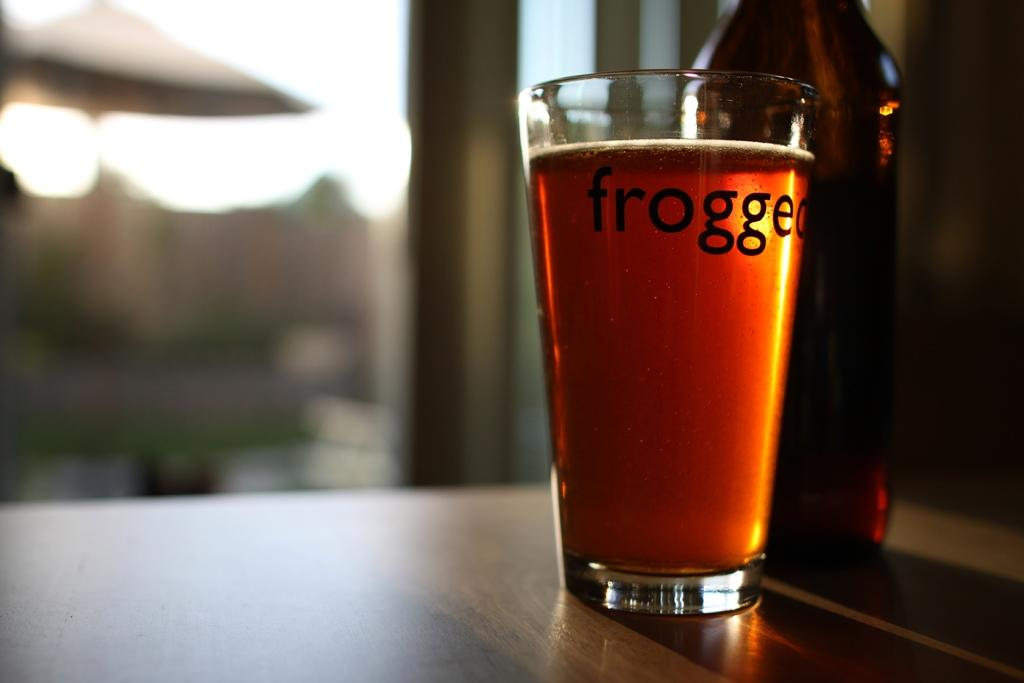<image>
Summarize the visual content of the image. A glass of beer with the first four letters spelling out frog on it is in front of a beer bottle and on a table. 